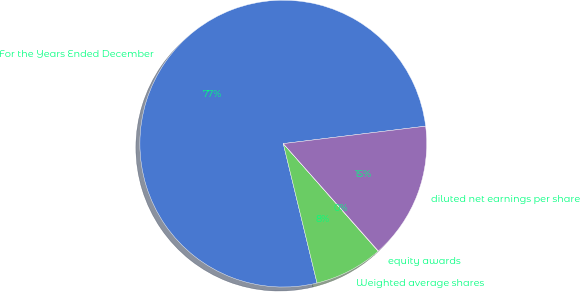<chart> <loc_0><loc_0><loc_500><loc_500><pie_chart><fcel>For the Years Ended December<fcel>Weighted average shares<fcel>equity awards<fcel>diluted net earnings per share<nl><fcel>76.84%<fcel>7.72%<fcel>0.04%<fcel>15.4%<nl></chart> 